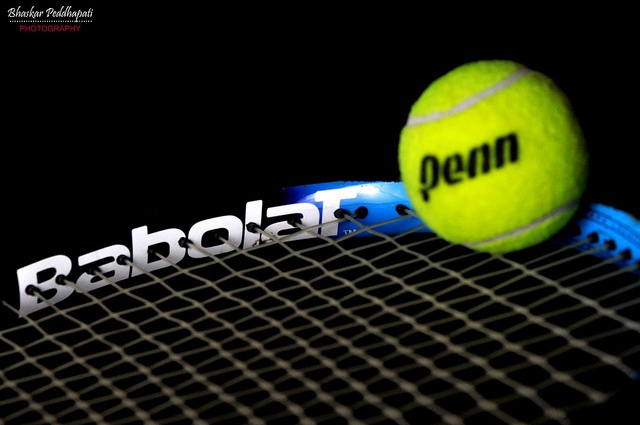Describe the objects in this image and their specific colors. I can see tennis racket in black, gray, and white tones and sports ball in black, khaki, yellow, and olive tones in this image. 